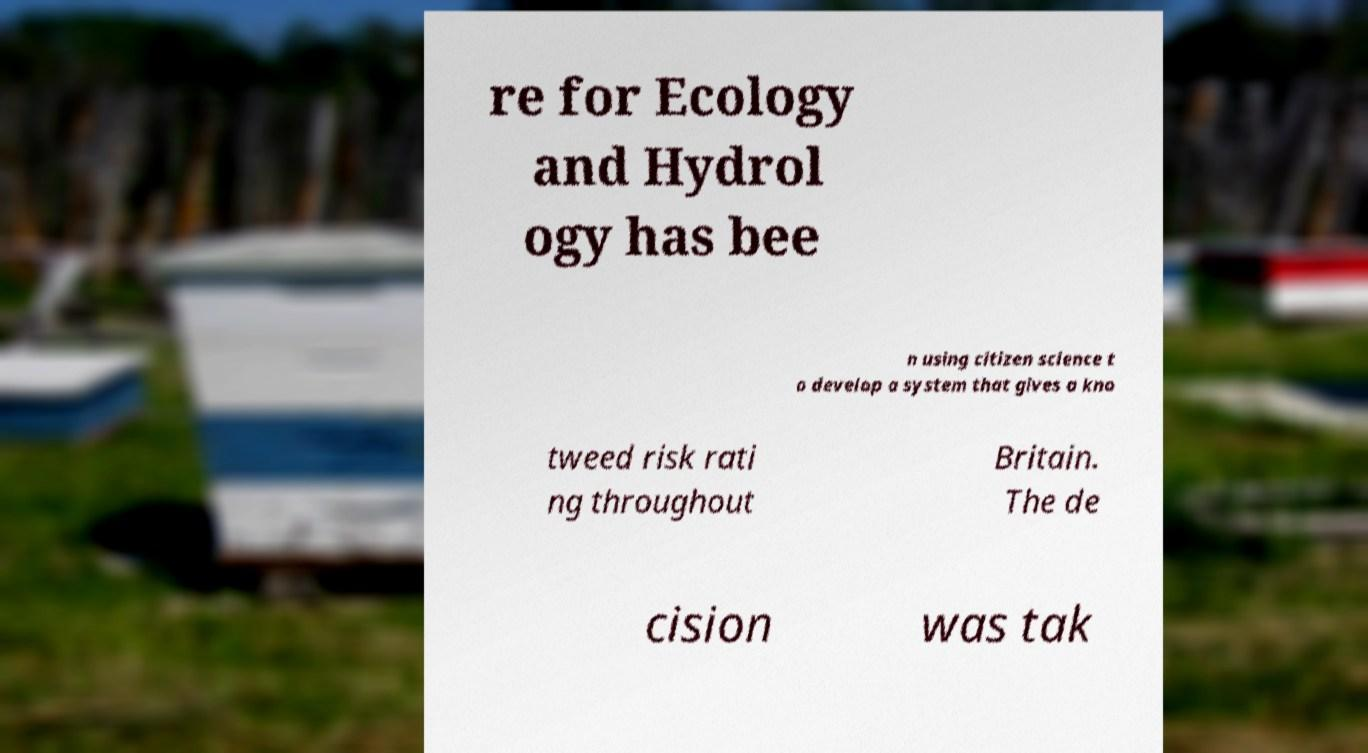I need the written content from this picture converted into text. Can you do that? re for Ecology and Hydrol ogy has bee n using citizen science t o develop a system that gives a kno tweed risk rati ng throughout Britain. The de cision was tak 